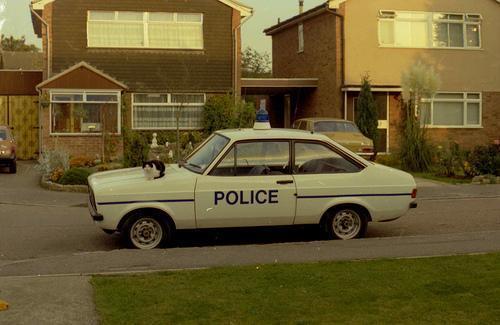How many police cars are there?
Give a very brief answer. 1. 